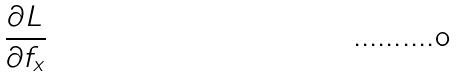<formula> <loc_0><loc_0><loc_500><loc_500>\frac { \partial L } { \partial f _ { x } }</formula> 